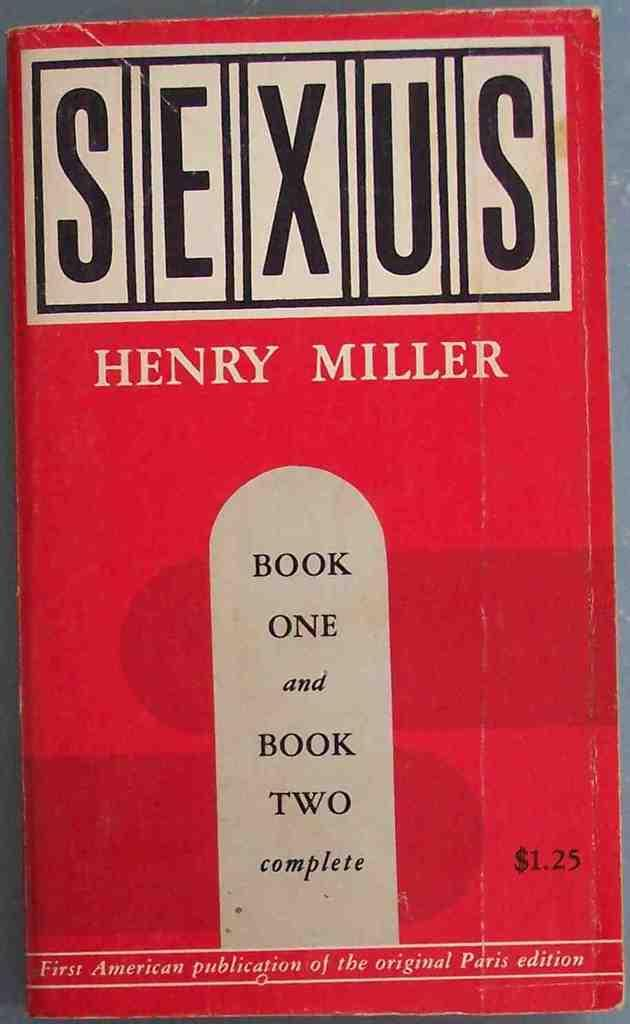<image>
Provide a brief description of the given image. A book titled Sexus by the author Henry Miller. 